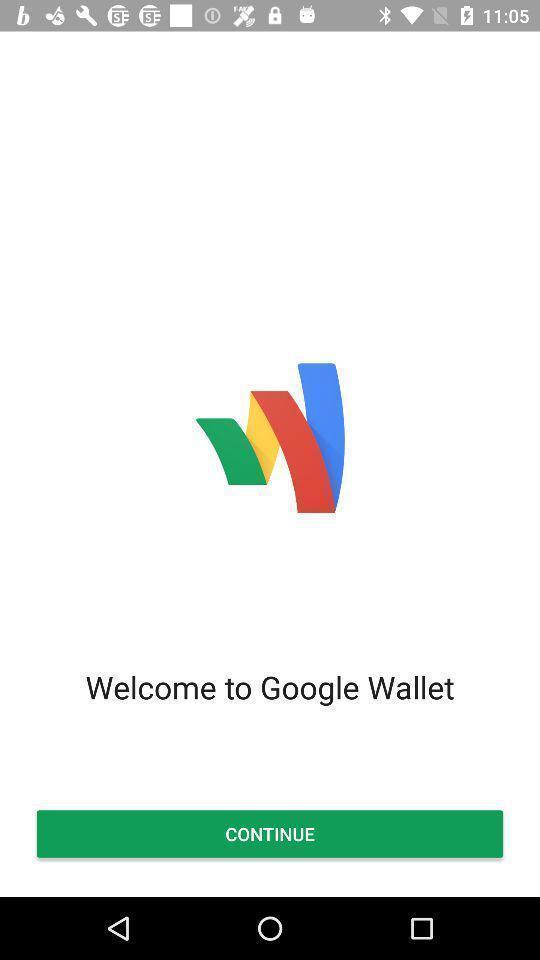Describe the key features of this screenshot. Welcome page to the application with option. 